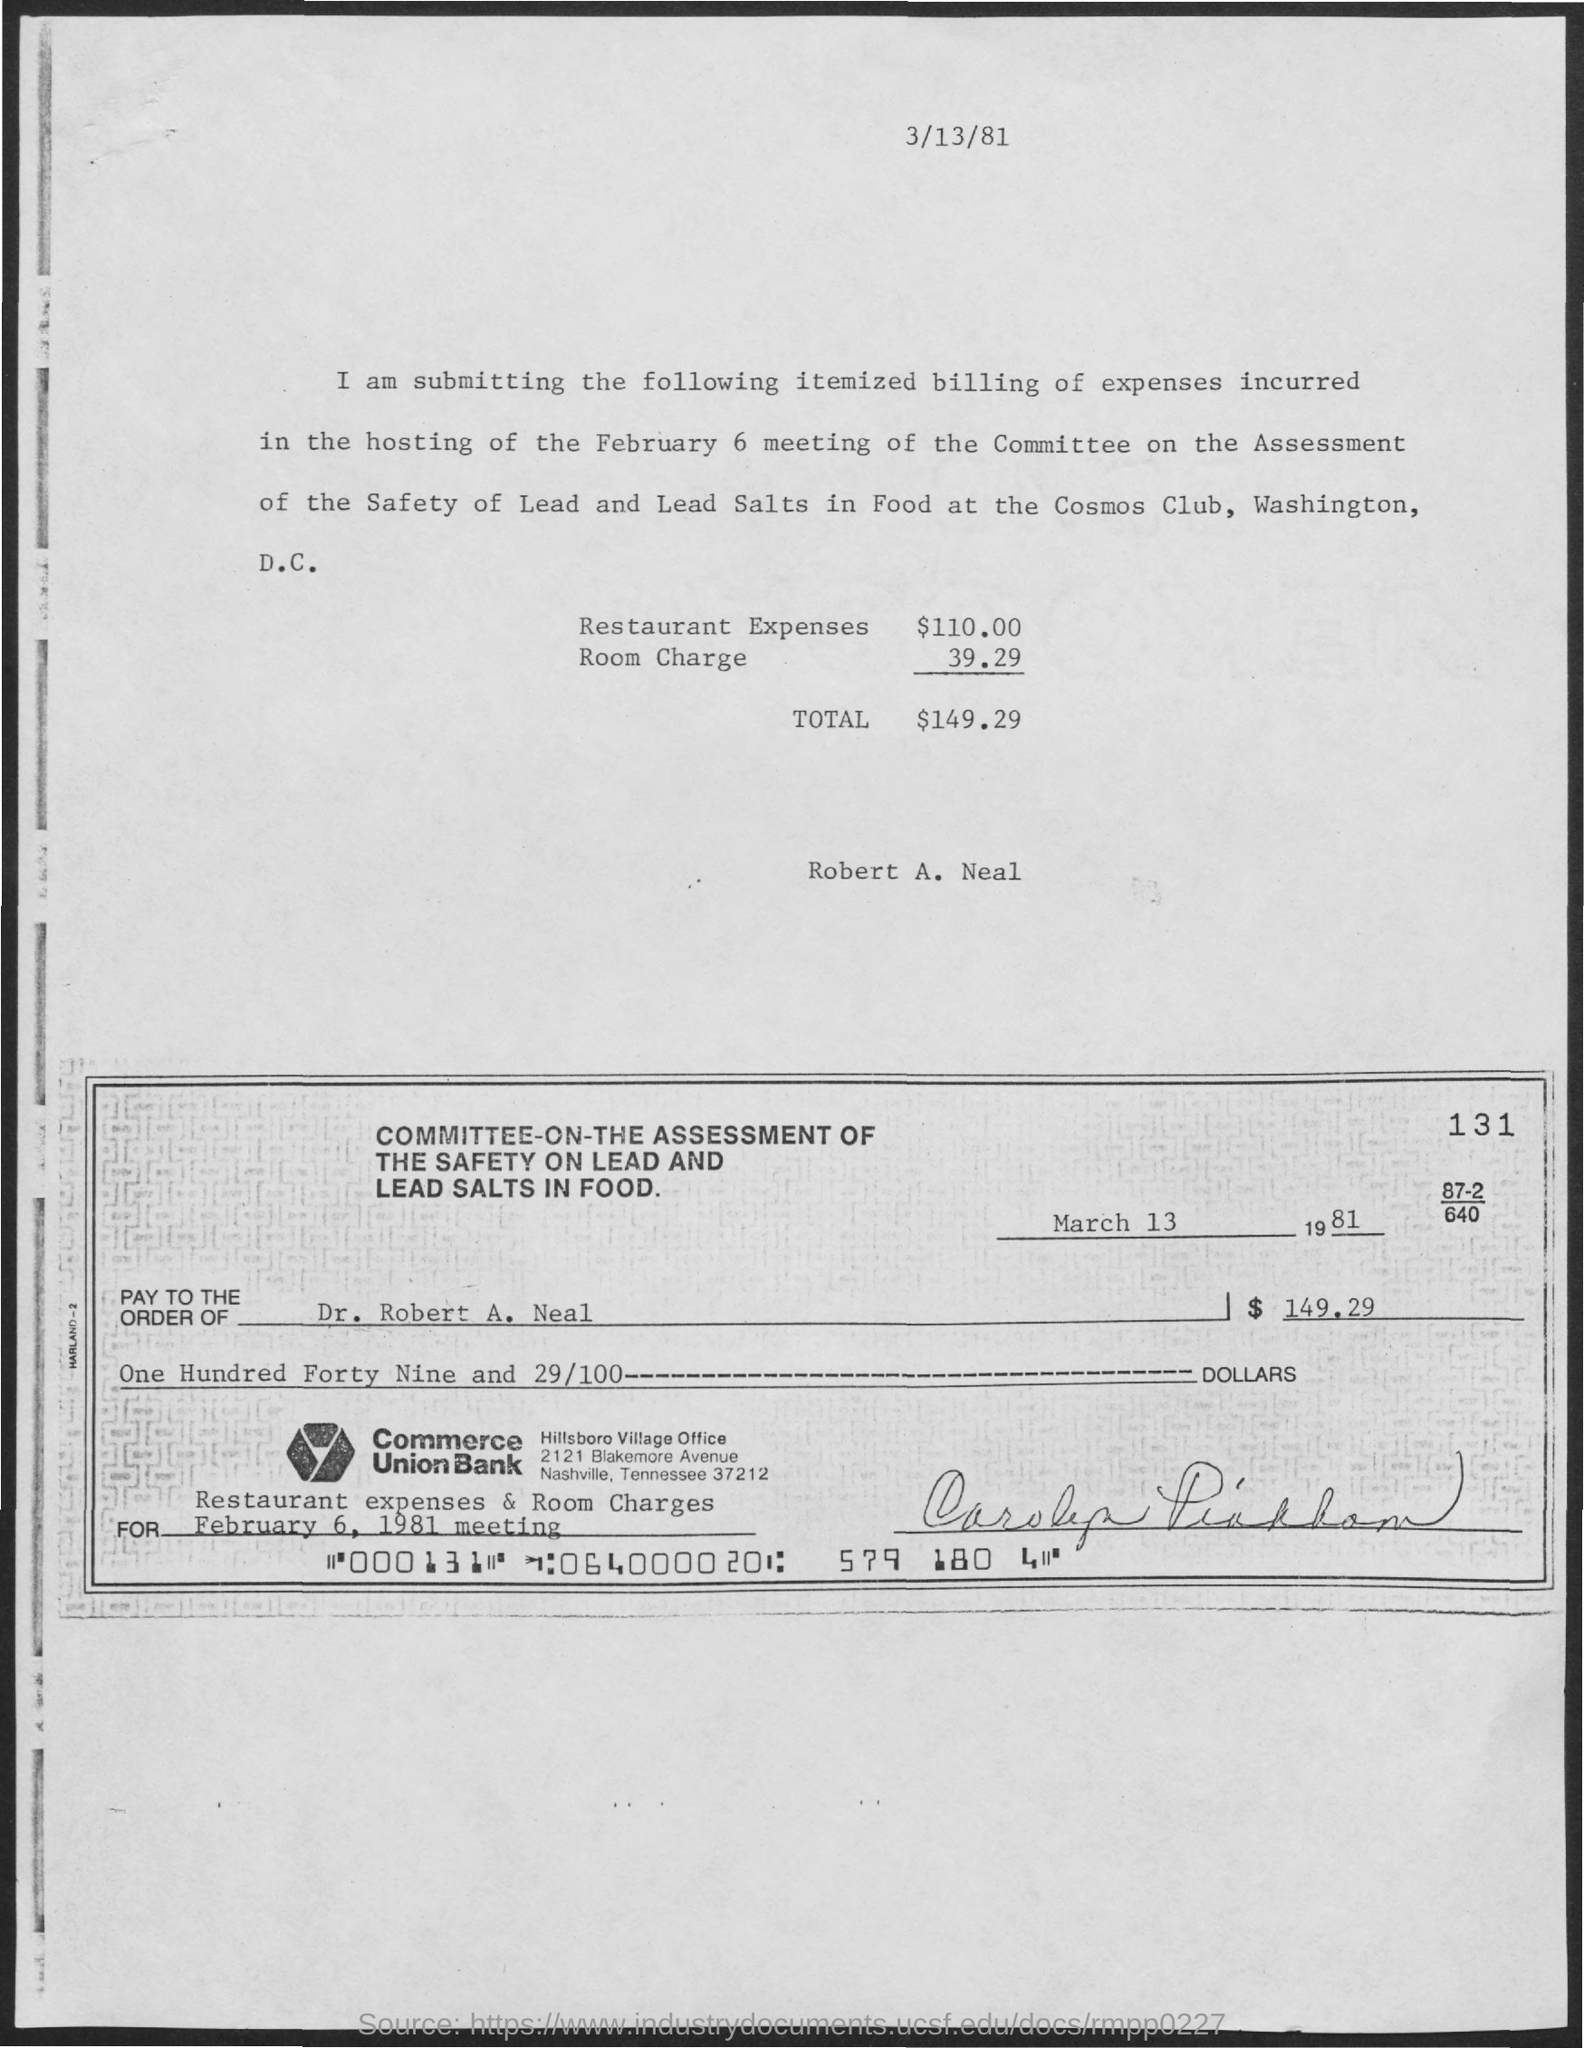Outline some significant characteristics in this image. The date mentioned at the top of the page is 3/13/81. The total amount mentioned is $149.29. What is the check number?" the customer inquired. "000131...," the customer replied. The name of the individual indicated on the cheque, as stated in the document above the cheque, is Robert A. Neal. The events and discussions that took place during the February 6, 1981 meeting are mentioned. 